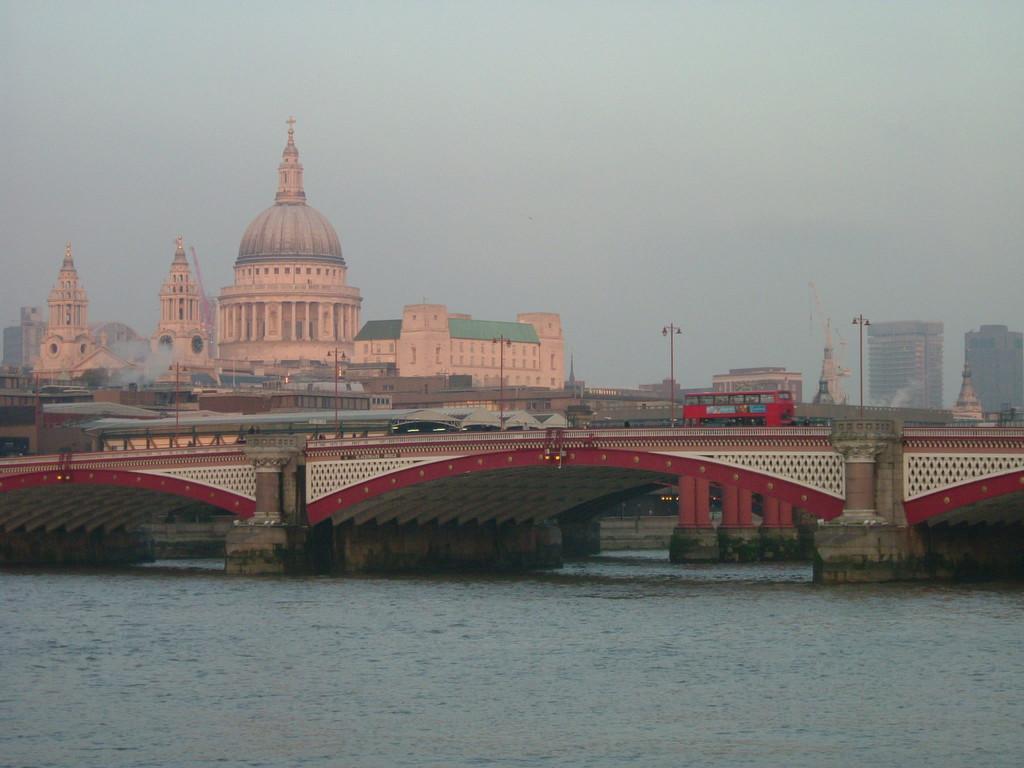Please provide a concise description of this image. In this picture, there is a bridge in the center. On the bridge, there are some vehicles. At the bottom, there is water. In the background, there are buildings and poles. On the top, there is a sky. 